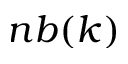Convert formula to latex. <formula><loc_0><loc_0><loc_500><loc_500>n b ( k )</formula> 